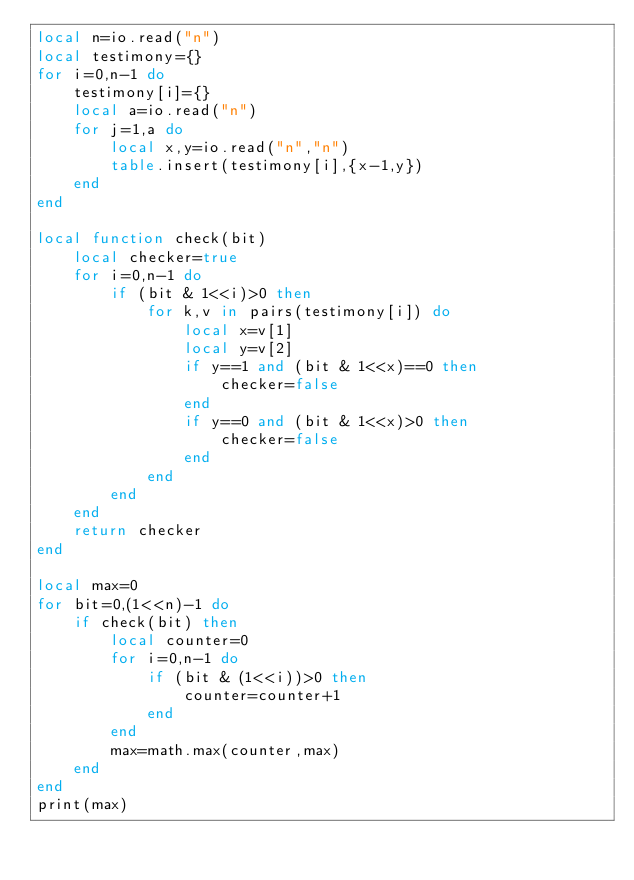<code> <loc_0><loc_0><loc_500><loc_500><_Lua_>local n=io.read("n")
local testimony={}
for i=0,n-1 do
    testimony[i]={}
    local a=io.read("n")
    for j=1,a do
        local x,y=io.read("n","n")
        table.insert(testimony[i],{x-1,y})
    end
end

local function check(bit)
    local checker=true
    for i=0,n-1 do
        if (bit & 1<<i)>0 then
            for k,v in pairs(testimony[i]) do
                local x=v[1]
                local y=v[2]
                if y==1 and (bit & 1<<x)==0 then
                    checker=false
                end
                if y==0 and (bit & 1<<x)>0 then
                    checker=false
                end
            end
        end
    end
    return checker
end

local max=0
for bit=0,(1<<n)-1 do
    if check(bit) then
        local counter=0
        for i=0,n-1 do
            if (bit & (1<<i))>0 then
                counter=counter+1
            end
        end
        max=math.max(counter,max)
    end
end
print(max)</code> 